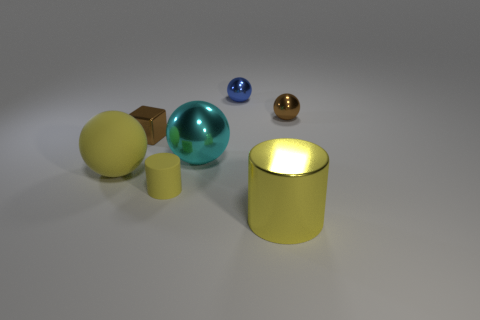Is there anything else that has the same material as the tiny block?
Provide a short and direct response. Yes. What number of other things are there of the same size as the shiny block?
Your answer should be compact. 3. The other cylinder that is the same color as the small cylinder is what size?
Provide a succinct answer. Large. What number of spheres are yellow objects or big cyan things?
Your answer should be very brief. 2. Does the tiny brown metal object right of the tiny block have the same shape as the big cyan object?
Make the answer very short. Yes. Is the number of blue metal balls that are in front of the block greater than the number of yellow shiny cylinders?
Keep it short and to the point. No. What is the color of the other sphere that is the same size as the blue metallic ball?
Make the answer very short. Brown. How many objects are brown spheres that are behind the small brown metallic block or small yellow rubber cylinders?
Give a very brief answer. 2. What is the shape of the small thing that is the same color as the metallic cylinder?
Provide a short and direct response. Cylinder. What material is the small brown thing on the right side of the tiny brown metallic object left of the cyan ball made of?
Provide a short and direct response. Metal. 